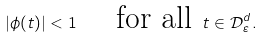Convert formula to latex. <formula><loc_0><loc_0><loc_500><loc_500>| \phi ( t ) | < 1 \quad \text { for all } t \in \mathcal { D } _ { \varepsilon } ^ { d } .</formula> 